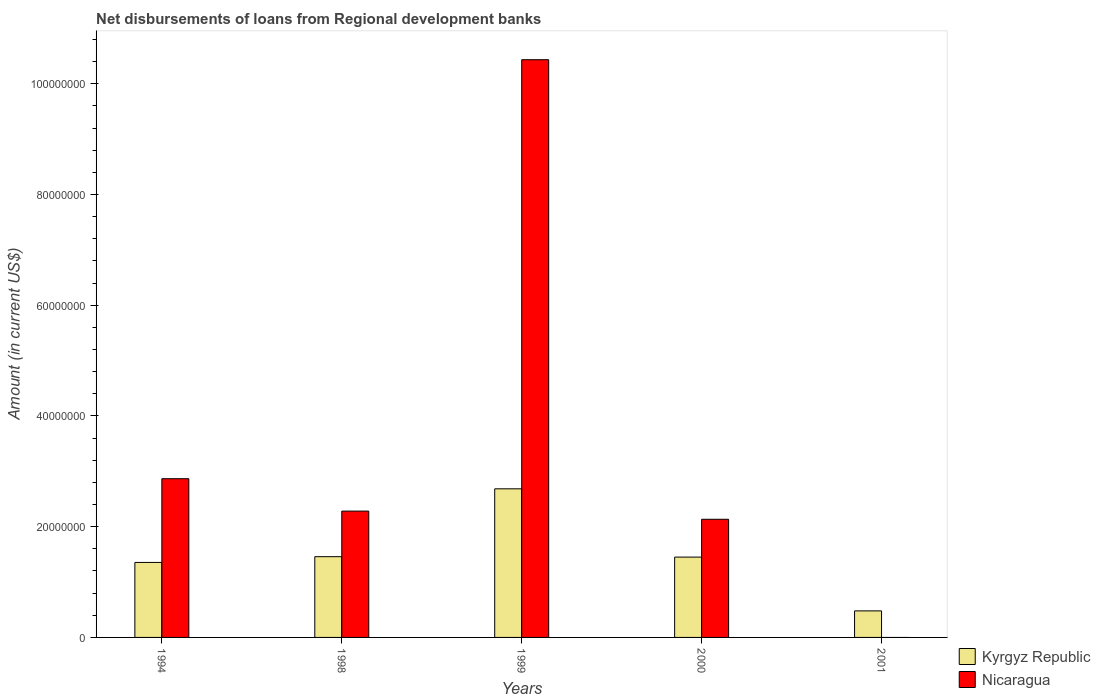Are the number of bars per tick equal to the number of legend labels?
Ensure brevity in your answer.  No. Are the number of bars on each tick of the X-axis equal?
Your answer should be very brief. No. How many bars are there on the 3rd tick from the right?
Your response must be concise. 2. What is the amount of disbursements of loans from regional development banks in Nicaragua in 1994?
Your answer should be compact. 2.87e+07. Across all years, what is the maximum amount of disbursements of loans from regional development banks in Nicaragua?
Provide a short and direct response. 1.04e+08. Across all years, what is the minimum amount of disbursements of loans from regional development banks in Nicaragua?
Offer a very short reply. 0. What is the total amount of disbursements of loans from regional development banks in Nicaragua in the graph?
Keep it short and to the point. 1.77e+08. What is the difference between the amount of disbursements of loans from regional development banks in Kyrgyz Republic in 1999 and that in 2000?
Your answer should be compact. 1.23e+07. What is the difference between the amount of disbursements of loans from regional development banks in Kyrgyz Republic in 2000 and the amount of disbursements of loans from regional development banks in Nicaragua in 2001?
Offer a very short reply. 1.45e+07. What is the average amount of disbursements of loans from regional development banks in Nicaragua per year?
Offer a terse response. 3.54e+07. In the year 1999, what is the difference between the amount of disbursements of loans from regional development banks in Nicaragua and amount of disbursements of loans from regional development banks in Kyrgyz Republic?
Offer a terse response. 7.75e+07. In how many years, is the amount of disbursements of loans from regional development banks in Nicaragua greater than 104000000 US$?
Give a very brief answer. 1. What is the ratio of the amount of disbursements of loans from regional development banks in Kyrgyz Republic in 1998 to that in 2001?
Your answer should be very brief. 3.04. What is the difference between the highest and the second highest amount of disbursements of loans from regional development banks in Kyrgyz Republic?
Offer a terse response. 1.23e+07. What is the difference between the highest and the lowest amount of disbursements of loans from regional development banks in Kyrgyz Republic?
Keep it short and to the point. 2.20e+07. Is the sum of the amount of disbursements of loans from regional development banks in Kyrgyz Republic in 1994 and 2000 greater than the maximum amount of disbursements of loans from regional development banks in Nicaragua across all years?
Your answer should be compact. No. How many bars are there?
Make the answer very short. 9. Are all the bars in the graph horizontal?
Make the answer very short. No. What is the difference between two consecutive major ticks on the Y-axis?
Keep it short and to the point. 2.00e+07. What is the title of the graph?
Your response must be concise. Net disbursements of loans from Regional development banks. What is the label or title of the X-axis?
Ensure brevity in your answer.  Years. What is the label or title of the Y-axis?
Keep it short and to the point. Amount (in current US$). What is the Amount (in current US$) of Kyrgyz Republic in 1994?
Provide a succinct answer. 1.35e+07. What is the Amount (in current US$) in Nicaragua in 1994?
Give a very brief answer. 2.87e+07. What is the Amount (in current US$) of Kyrgyz Republic in 1998?
Provide a short and direct response. 1.46e+07. What is the Amount (in current US$) in Nicaragua in 1998?
Your answer should be compact. 2.28e+07. What is the Amount (in current US$) in Kyrgyz Republic in 1999?
Offer a terse response. 2.68e+07. What is the Amount (in current US$) of Nicaragua in 1999?
Provide a succinct answer. 1.04e+08. What is the Amount (in current US$) in Kyrgyz Republic in 2000?
Provide a short and direct response. 1.45e+07. What is the Amount (in current US$) in Nicaragua in 2000?
Your answer should be compact. 2.13e+07. What is the Amount (in current US$) of Kyrgyz Republic in 2001?
Your answer should be very brief. 4.79e+06. What is the Amount (in current US$) in Nicaragua in 2001?
Offer a terse response. 0. Across all years, what is the maximum Amount (in current US$) of Kyrgyz Republic?
Ensure brevity in your answer.  2.68e+07. Across all years, what is the maximum Amount (in current US$) of Nicaragua?
Offer a very short reply. 1.04e+08. Across all years, what is the minimum Amount (in current US$) of Kyrgyz Republic?
Offer a very short reply. 4.79e+06. Across all years, what is the minimum Amount (in current US$) of Nicaragua?
Your answer should be compact. 0. What is the total Amount (in current US$) of Kyrgyz Republic in the graph?
Provide a short and direct response. 7.43e+07. What is the total Amount (in current US$) of Nicaragua in the graph?
Provide a succinct answer. 1.77e+08. What is the difference between the Amount (in current US$) in Kyrgyz Republic in 1994 and that in 1998?
Offer a terse response. -1.04e+06. What is the difference between the Amount (in current US$) of Nicaragua in 1994 and that in 1998?
Give a very brief answer. 5.85e+06. What is the difference between the Amount (in current US$) of Kyrgyz Republic in 1994 and that in 1999?
Ensure brevity in your answer.  -1.33e+07. What is the difference between the Amount (in current US$) in Nicaragua in 1994 and that in 1999?
Offer a terse response. -7.57e+07. What is the difference between the Amount (in current US$) in Kyrgyz Republic in 1994 and that in 2000?
Your answer should be compact. -9.61e+05. What is the difference between the Amount (in current US$) of Nicaragua in 1994 and that in 2000?
Ensure brevity in your answer.  7.33e+06. What is the difference between the Amount (in current US$) of Kyrgyz Republic in 1994 and that in 2001?
Offer a very short reply. 8.75e+06. What is the difference between the Amount (in current US$) of Kyrgyz Republic in 1998 and that in 1999?
Make the answer very short. -1.23e+07. What is the difference between the Amount (in current US$) in Nicaragua in 1998 and that in 1999?
Give a very brief answer. -8.15e+07. What is the difference between the Amount (in current US$) in Kyrgyz Republic in 1998 and that in 2000?
Keep it short and to the point. 7.70e+04. What is the difference between the Amount (in current US$) of Nicaragua in 1998 and that in 2000?
Keep it short and to the point. 1.48e+06. What is the difference between the Amount (in current US$) of Kyrgyz Republic in 1998 and that in 2001?
Keep it short and to the point. 9.79e+06. What is the difference between the Amount (in current US$) of Kyrgyz Republic in 1999 and that in 2000?
Provide a short and direct response. 1.23e+07. What is the difference between the Amount (in current US$) of Nicaragua in 1999 and that in 2000?
Offer a very short reply. 8.30e+07. What is the difference between the Amount (in current US$) of Kyrgyz Republic in 1999 and that in 2001?
Provide a short and direct response. 2.20e+07. What is the difference between the Amount (in current US$) in Kyrgyz Republic in 2000 and that in 2001?
Ensure brevity in your answer.  9.71e+06. What is the difference between the Amount (in current US$) of Kyrgyz Republic in 1994 and the Amount (in current US$) of Nicaragua in 1998?
Your answer should be very brief. -9.27e+06. What is the difference between the Amount (in current US$) of Kyrgyz Republic in 1994 and the Amount (in current US$) of Nicaragua in 1999?
Your answer should be compact. -9.08e+07. What is the difference between the Amount (in current US$) of Kyrgyz Republic in 1994 and the Amount (in current US$) of Nicaragua in 2000?
Keep it short and to the point. -7.80e+06. What is the difference between the Amount (in current US$) in Kyrgyz Republic in 1998 and the Amount (in current US$) in Nicaragua in 1999?
Offer a terse response. -8.98e+07. What is the difference between the Amount (in current US$) of Kyrgyz Republic in 1998 and the Amount (in current US$) of Nicaragua in 2000?
Your answer should be compact. -6.76e+06. What is the difference between the Amount (in current US$) of Kyrgyz Republic in 1999 and the Amount (in current US$) of Nicaragua in 2000?
Your response must be concise. 5.50e+06. What is the average Amount (in current US$) of Kyrgyz Republic per year?
Provide a short and direct response. 1.49e+07. What is the average Amount (in current US$) of Nicaragua per year?
Offer a terse response. 3.54e+07. In the year 1994, what is the difference between the Amount (in current US$) of Kyrgyz Republic and Amount (in current US$) of Nicaragua?
Your answer should be very brief. -1.51e+07. In the year 1998, what is the difference between the Amount (in current US$) in Kyrgyz Republic and Amount (in current US$) in Nicaragua?
Give a very brief answer. -8.23e+06. In the year 1999, what is the difference between the Amount (in current US$) of Kyrgyz Republic and Amount (in current US$) of Nicaragua?
Your answer should be very brief. -7.75e+07. In the year 2000, what is the difference between the Amount (in current US$) in Kyrgyz Republic and Amount (in current US$) in Nicaragua?
Offer a very short reply. -6.83e+06. What is the ratio of the Amount (in current US$) of Kyrgyz Republic in 1994 to that in 1998?
Give a very brief answer. 0.93. What is the ratio of the Amount (in current US$) in Nicaragua in 1994 to that in 1998?
Provide a short and direct response. 1.26. What is the ratio of the Amount (in current US$) in Kyrgyz Republic in 1994 to that in 1999?
Provide a short and direct response. 0.5. What is the ratio of the Amount (in current US$) in Nicaragua in 1994 to that in 1999?
Your answer should be very brief. 0.27. What is the ratio of the Amount (in current US$) in Kyrgyz Republic in 1994 to that in 2000?
Provide a succinct answer. 0.93. What is the ratio of the Amount (in current US$) of Nicaragua in 1994 to that in 2000?
Your response must be concise. 1.34. What is the ratio of the Amount (in current US$) of Kyrgyz Republic in 1994 to that in 2001?
Your response must be concise. 2.83. What is the ratio of the Amount (in current US$) of Kyrgyz Republic in 1998 to that in 1999?
Ensure brevity in your answer.  0.54. What is the ratio of the Amount (in current US$) of Nicaragua in 1998 to that in 1999?
Your answer should be compact. 0.22. What is the ratio of the Amount (in current US$) in Kyrgyz Republic in 1998 to that in 2000?
Offer a terse response. 1.01. What is the ratio of the Amount (in current US$) of Nicaragua in 1998 to that in 2000?
Offer a very short reply. 1.07. What is the ratio of the Amount (in current US$) in Kyrgyz Republic in 1998 to that in 2001?
Your answer should be very brief. 3.04. What is the ratio of the Amount (in current US$) of Kyrgyz Republic in 1999 to that in 2000?
Offer a terse response. 1.85. What is the ratio of the Amount (in current US$) in Nicaragua in 1999 to that in 2000?
Offer a very short reply. 4.89. What is the ratio of the Amount (in current US$) of Kyrgyz Republic in 1999 to that in 2001?
Keep it short and to the point. 5.6. What is the ratio of the Amount (in current US$) of Kyrgyz Republic in 2000 to that in 2001?
Give a very brief answer. 3.03. What is the difference between the highest and the second highest Amount (in current US$) in Kyrgyz Republic?
Ensure brevity in your answer.  1.23e+07. What is the difference between the highest and the second highest Amount (in current US$) of Nicaragua?
Your answer should be compact. 7.57e+07. What is the difference between the highest and the lowest Amount (in current US$) in Kyrgyz Republic?
Your answer should be compact. 2.20e+07. What is the difference between the highest and the lowest Amount (in current US$) of Nicaragua?
Keep it short and to the point. 1.04e+08. 